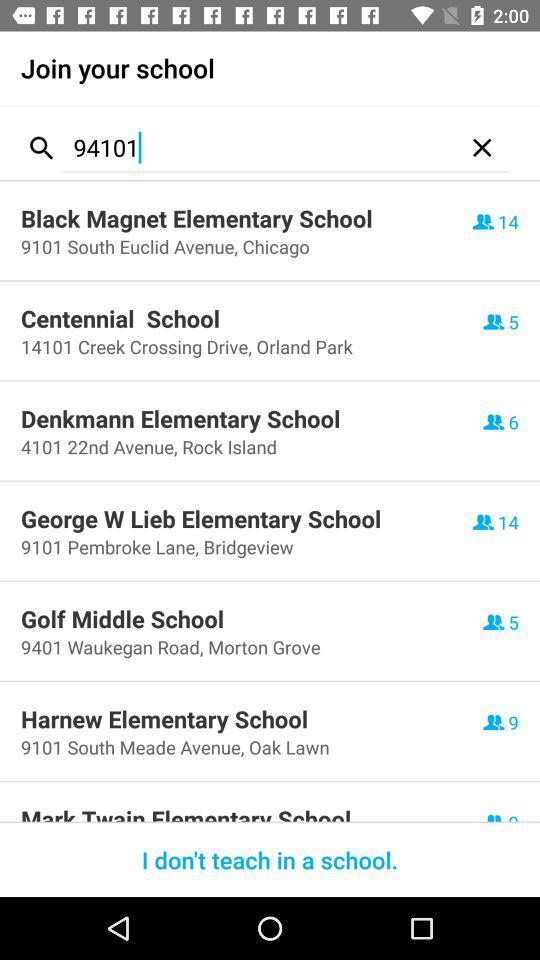Where is Golf Middle School located? It is located at 9401 Waukegan Road, Morton Grove. 